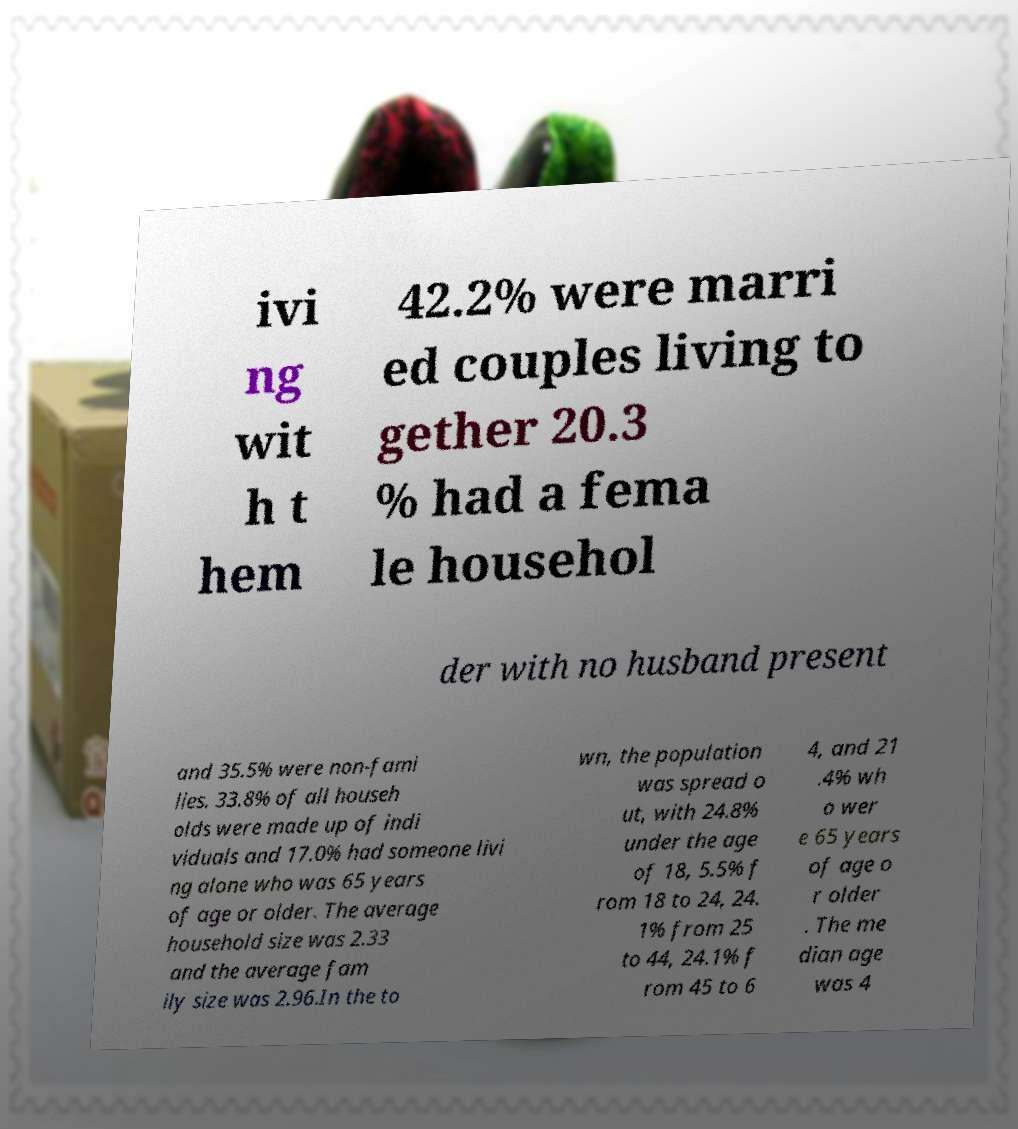I need the written content from this picture converted into text. Can you do that? ivi ng wit h t hem 42.2% were marri ed couples living to gether 20.3 % had a fema le househol der with no husband present and 35.5% were non-fami lies. 33.8% of all househ olds were made up of indi viduals and 17.0% had someone livi ng alone who was 65 years of age or older. The average household size was 2.33 and the average fam ily size was 2.96.In the to wn, the population was spread o ut, with 24.8% under the age of 18, 5.5% f rom 18 to 24, 24. 1% from 25 to 44, 24.1% f rom 45 to 6 4, and 21 .4% wh o wer e 65 years of age o r older . The me dian age was 4 